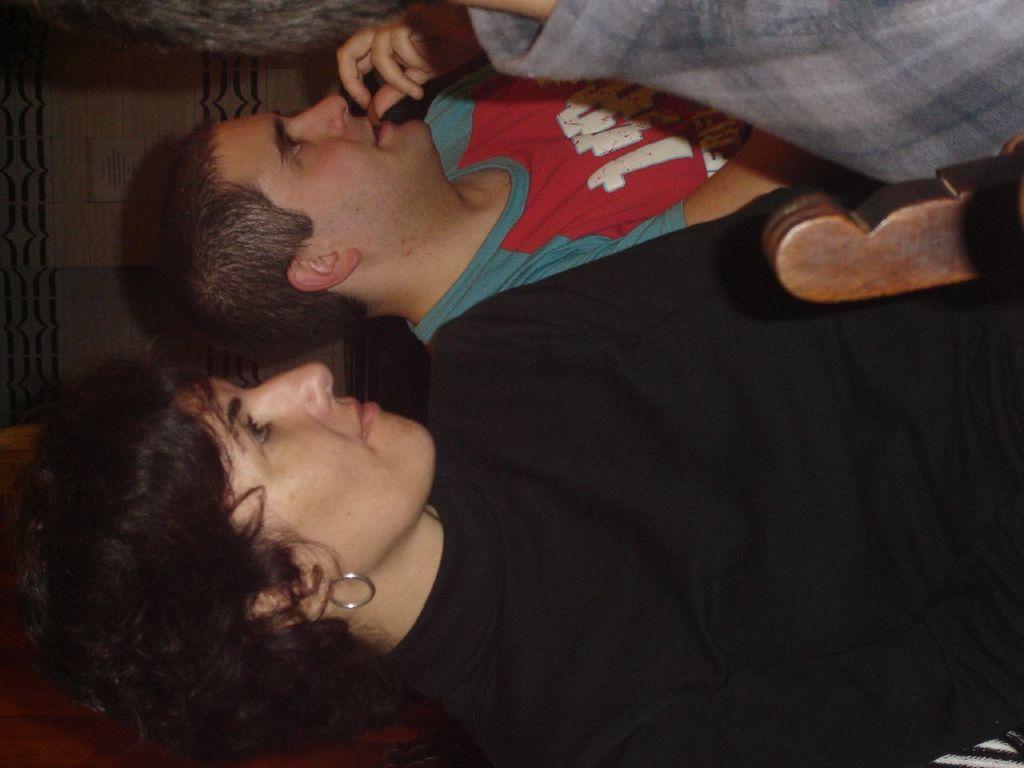Can you describe this image briefly? In this picture I can see a man, woman, in front of them I can see another person and wooden thing. 